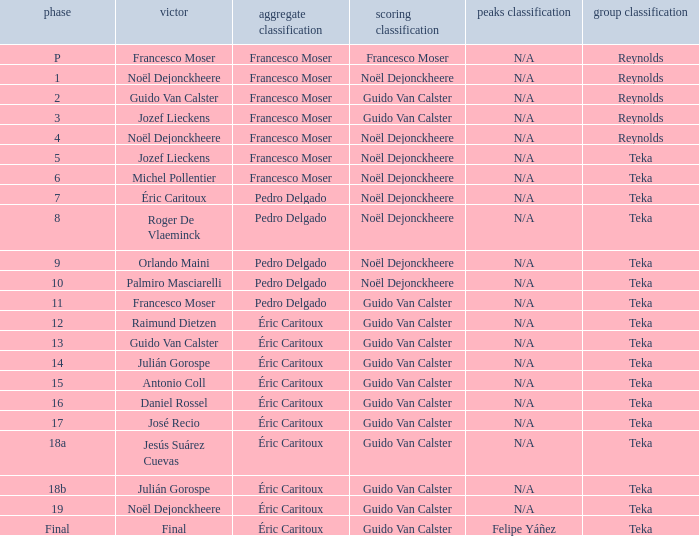Name the points classification of stage 16 Guido Van Calster. 